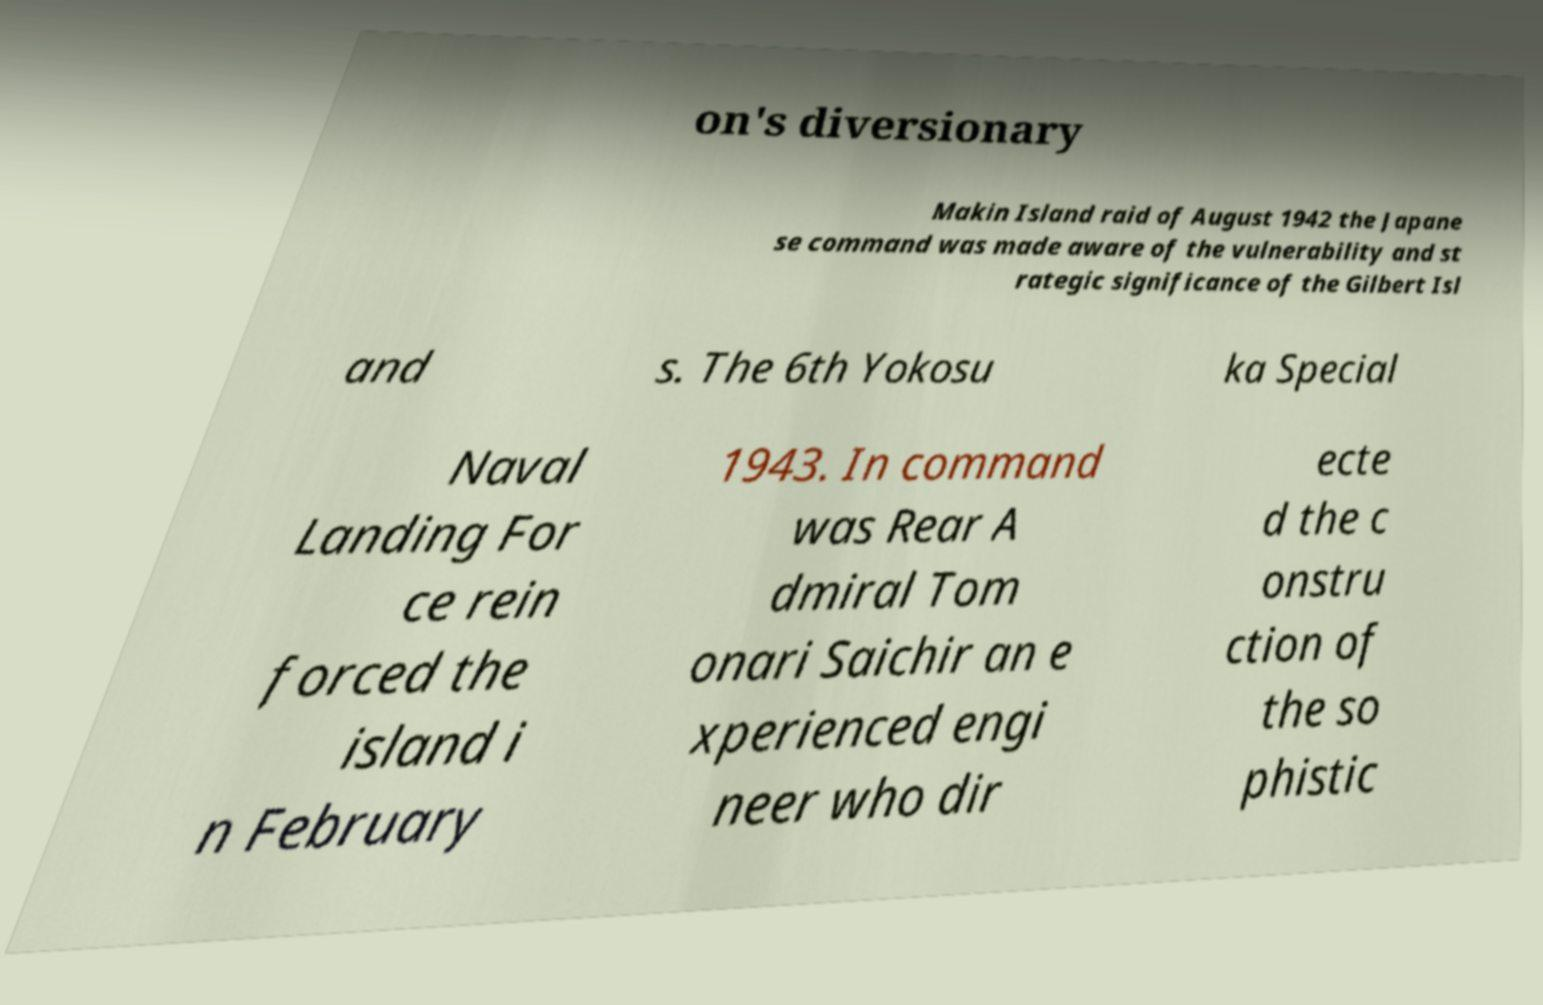There's text embedded in this image that I need extracted. Can you transcribe it verbatim? on's diversionary Makin Island raid of August 1942 the Japane se command was made aware of the vulnerability and st rategic significance of the Gilbert Isl and s. The 6th Yokosu ka Special Naval Landing For ce rein forced the island i n February 1943. In command was Rear A dmiral Tom onari Saichir an e xperienced engi neer who dir ecte d the c onstru ction of the so phistic 